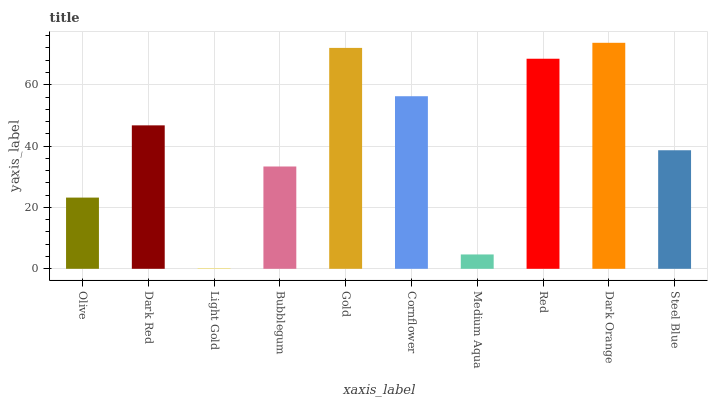Is Light Gold the minimum?
Answer yes or no. Yes. Is Dark Orange the maximum?
Answer yes or no. Yes. Is Dark Red the minimum?
Answer yes or no. No. Is Dark Red the maximum?
Answer yes or no. No. Is Dark Red greater than Olive?
Answer yes or no. Yes. Is Olive less than Dark Red?
Answer yes or no. Yes. Is Olive greater than Dark Red?
Answer yes or no. No. Is Dark Red less than Olive?
Answer yes or no. No. Is Dark Red the high median?
Answer yes or no. Yes. Is Steel Blue the low median?
Answer yes or no. Yes. Is Cornflower the high median?
Answer yes or no. No. Is Gold the low median?
Answer yes or no. No. 